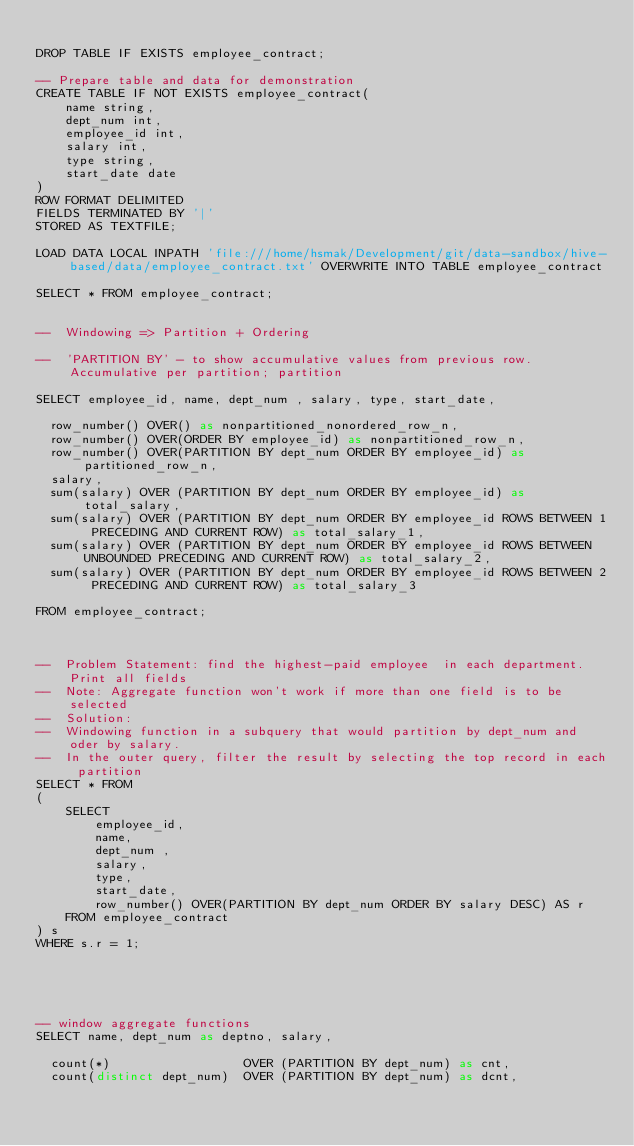<code> <loc_0><loc_0><loc_500><loc_500><_SQL_>
DROP TABLE IF EXISTS employee_contract;

-- Prepare table and data for demonstration
CREATE TABLE IF NOT EXISTS employee_contract(
    name string,
    dept_num int,
    employee_id int,
    salary int,
    type string,
    start_date date
)
ROW FORMAT DELIMITED
FIELDS TERMINATED BY '|'
STORED AS TEXTFILE;

LOAD DATA LOCAL INPATH 'file:///home/hsmak/Development/git/data-sandbox/hive-based/data/employee_contract.txt' OVERWRITE INTO TABLE employee_contract

SELECT * FROM employee_contract;


--  Windowing => Partition + Ordering

--  'PARTITION BY' - to show accumulative values from previous row. Accumulative per partition; partition

SELECT employee_id, name, dept_num , salary, type, start_date,

  row_number() OVER() as nonpartitioned_nonordered_row_n,
  row_number() OVER(ORDER BY employee_id) as nonpartitioned_row_n,
  row_number() OVER(PARTITION BY dept_num ORDER BY employee_id) as partitioned_row_n,
  salary,
  sum(salary) OVER (PARTITION BY dept_num ORDER BY employee_id) as total_salary,
  sum(salary) OVER (PARTITION BY dept_num ORDER BY employee_id ROWS BETWEEN 1 PRECEDING AND CURRENT ROW) as total_salary_1,
  sum(salary) OVER (PARTITION BY dept_num ORDER BY employee_id ROWS BETWEEN UNBOUNDED PRECEDING AND CURRENT ROW) as total_salary_2,
  sum(salary) OVER (PARTITION BY dept_num ORDER BY employee_id ROWS BETWEEN 2 PRECEDING AND CURRENT ROW) as total_salary_3

FROM employee_contract;



--  Problem Statement: find the highest-paid employee  in each department. Print all fields
--  Note: Aggregate function won't work if more than one field is to be selected
--  Solution:
--  Windowing function in a subquery that would partition by dept_num and oder by salary.
--  In the outer query, filter the result by selecting the top record in each partition
SELECT * FROM
(
    SELECT
        employee_id,
        name,
        dept_num ,
        salary,
        type,
        start_date,
        row_number() OVER(PARTITION BY dept_num ORDER BY salary DESC) AS r
    FROM employee_contract
) s
WHERE s.r = 1;





-- window aggregate functions
SELECT name, dept_num as deptno, salary,

  count(*)                  OVER (PARTITION BY dept_num) as cnt,
  count(distinct dept_num)  OVER (PARTITION BY dept_num) as dcnt,</code> 